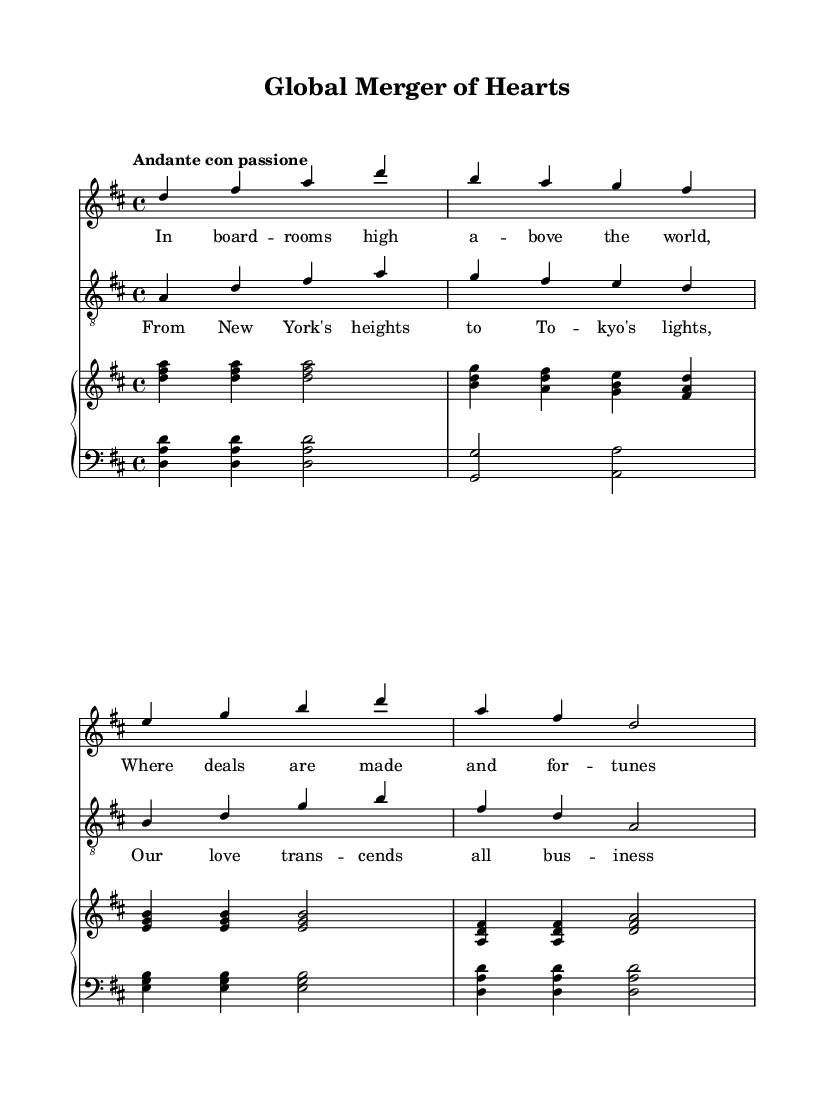What is the key signature of this music? The key signature is D major, which has two sharps (F# and C#). This can be determined by looking at the key signature indicated at the beginning of the staff, which shows the two sharp symbols.
Answer: D major What is the time signature of this music? The time signature is 4/4, which means there are four beats in a measure and the quarter note gets one beat. This is noted at the beginning of the score where the time signature is displayed.
Answer: 4/4 What is the tempo marking for this piece? The tempo marking is "Andante con passione," which indicates a moderate pace with passion. This marking is shown at the beginning of the score, indicating how the piece should be performed.
Answer: Andante con passione How many measures does the soprano part have? The soprano part has four measures, which can be counted by looking at the barlines separating the sections of music in the soprano staff.
Answer: 4 What type of musical form is being used in this duet? The duet employs a strophic form since it consists of repeated musical sections with different lyrics; this is evident from the structure of the lyrics corresponding to the melody.
Answer: Strophic In which business locations are referenced in the lyrics? The lyrics reference New York and Tokyo, which are noted in the second verse. This can be identified by reading the text in the lyric mode provided in the score.
Answer: New York, Tokyo What type of musical accompaniment is used for this duet? The duet utilizes a piano accompaniment, as shown by the two piano staves notated below the vocal lines, which support the soprano and tenor parts.
Answer: Piano 